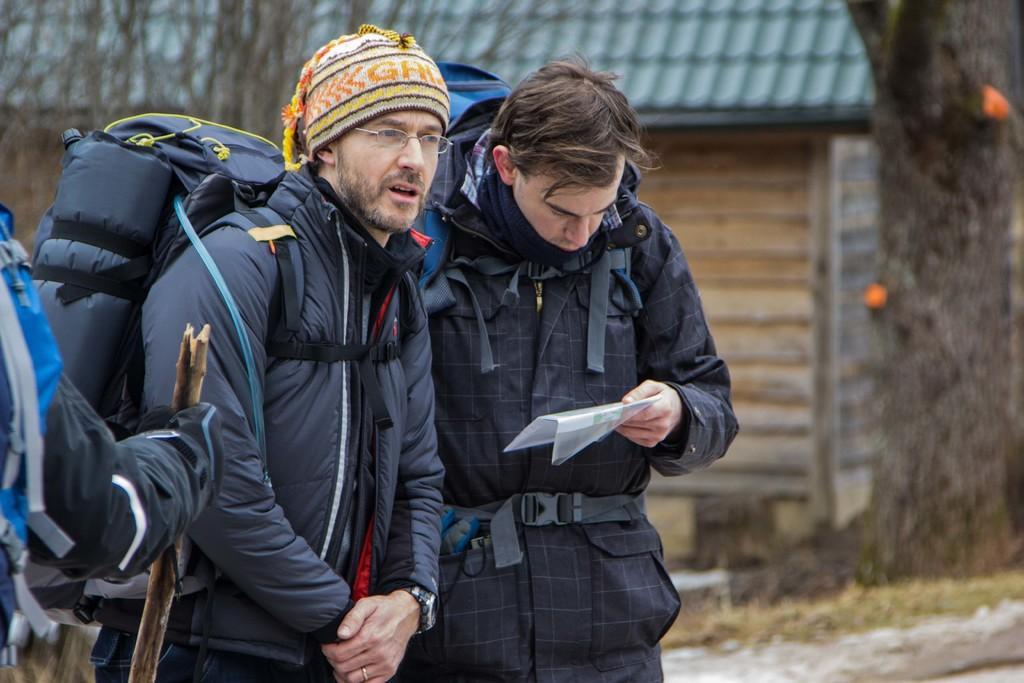Could you give a brief overview of what you see in this image? 2 people are standing. the person at the right is reading. behind him there is a room and trees. 